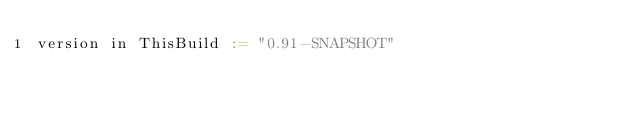Convert code to text. <code><loc_0><loc_0><loc_500><loc_500><_Scala_>version in ThisBuild := "0.91-SNAPSHOT"
</code> 